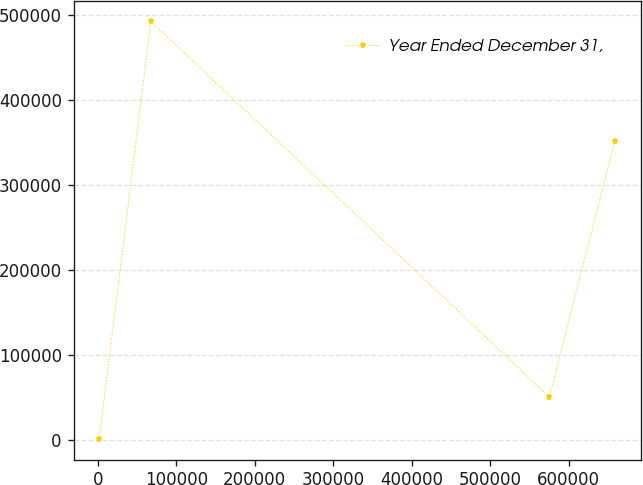Convert chart to OTSL. <chart><loc_0><loc_0><loc_500><loc_500><line_chart><ecel><fcel>Year Ended December 31,<nl><fcel>1738.19<fcel>1683.92<nl><fcel>67467.5<fcel>492170<nl><fcel>575480<fcel>50732.5<nl><fcel>659031<fcel>351450<nl></chart> 